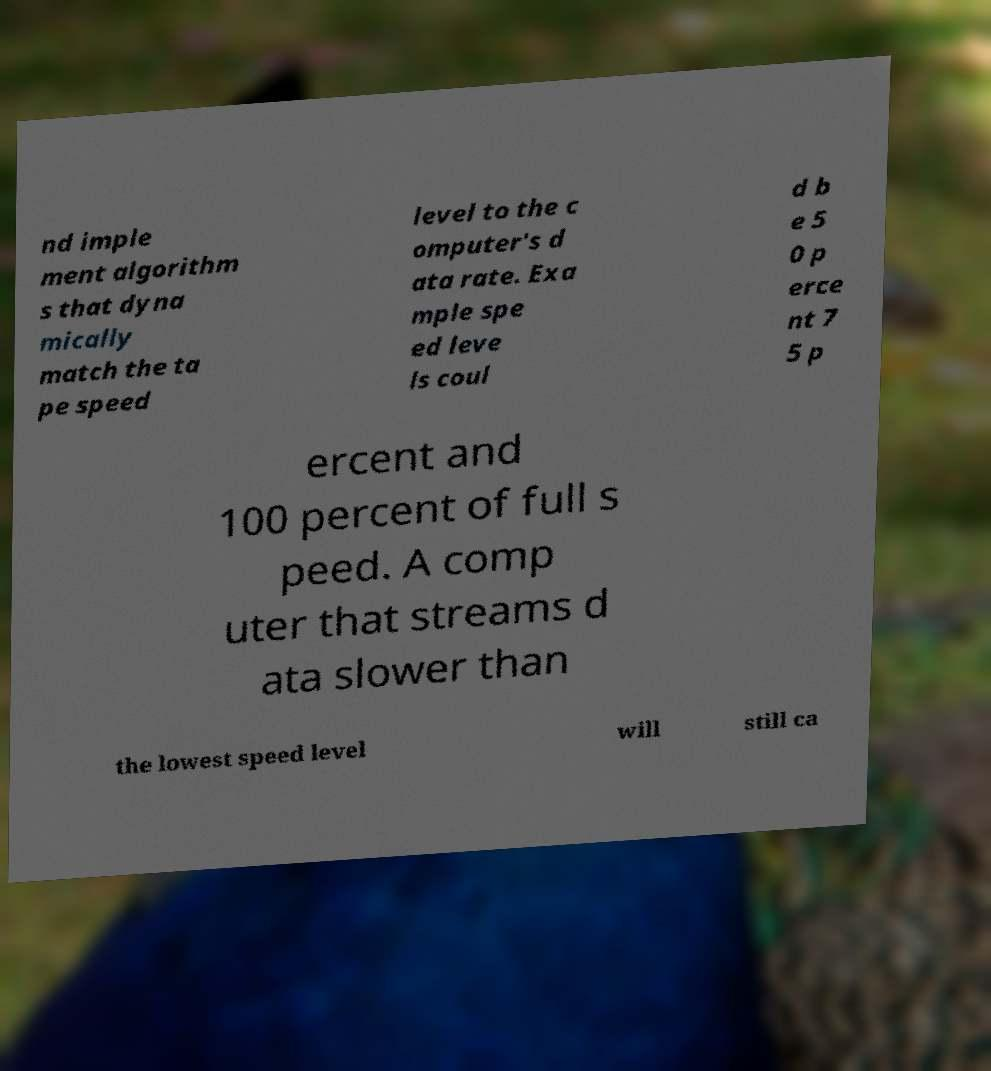Could you assist in decoding the text presented in this image and type it out clearly? nd imple ment algorithm s that dyna mically match the ta pe speed level to the c omputer's d ata rate. Exa mple spe ed leve ls coul d b e 5 0 p erce nt 7 5 p ercent and 100 percent of full s peed. A comp uter that streams d ata slower than the lowest speed level will still ca 